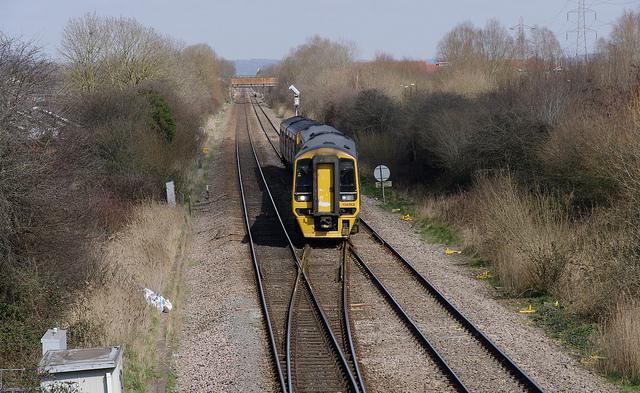How many tracks can you spot?
Give a very brief answer. 3. How many people are outside of the train?
Give a very brief answer. 0. 